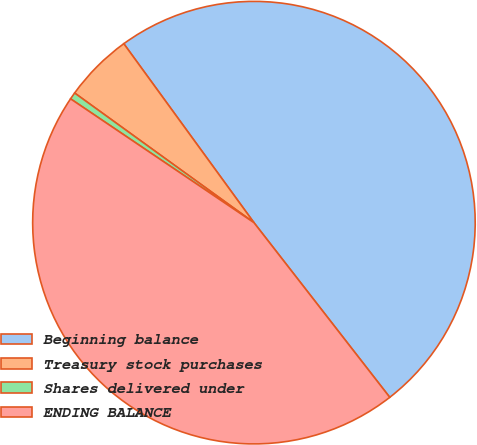<chart> <loc_0><loc_0><loc_500><loc_500><pie_chart><fcel>Beginning balance<fcel>Treasury stock purchases<fcel>Shares delivered under<fcel>ENDING BALANCE<nl><fcel>49.49%<fcel>5.03%<fcel>0.51%<fcel>44.97%<nl></chart> 